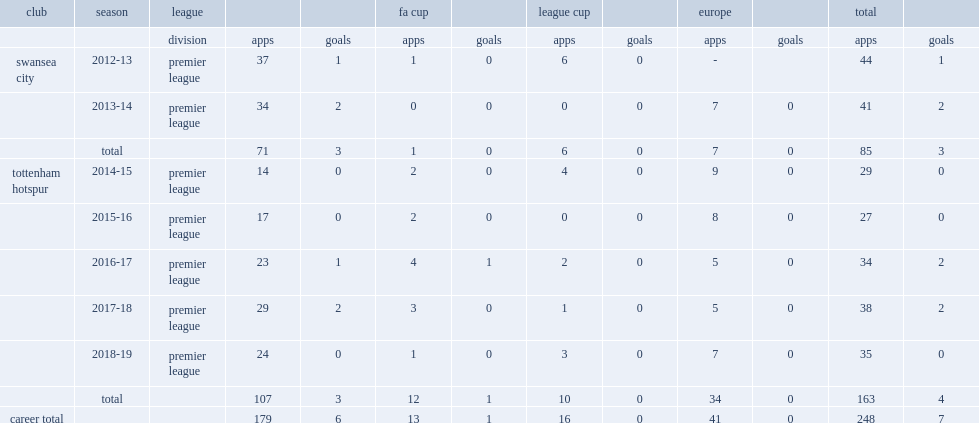Which league did ben davies make his debut for swansea city in the 2012-13 season? Premier league. 